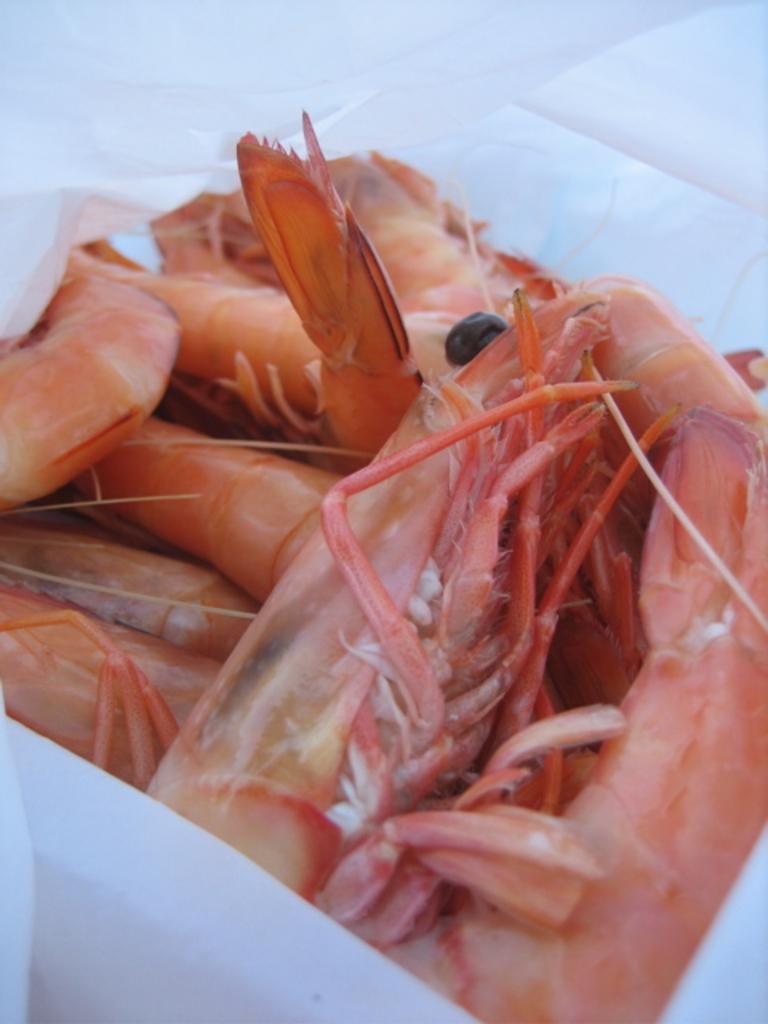Describe this image in one or two sentences. In this image we can see prawns kept in the white color cover. 